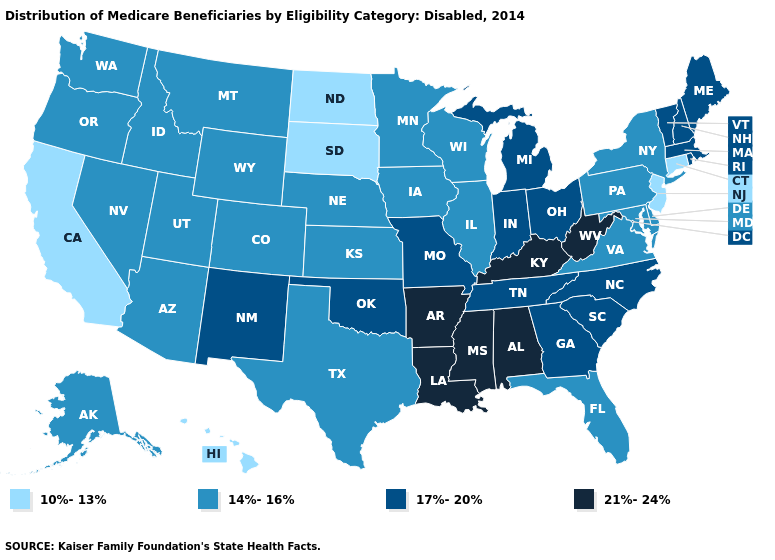What is the value of Hawaii?
Give a very brief answer. 10%-13%. What is the value of Connecticut?
Give a very brief answer. 10%-13%. What is the value of Colorado?
Write a very short answer. 14%-16%. Which states have the lowest value in the USA?
Quick response, please. California, Connecticut, Hawaii, New Jersey, North Dakota, South Dakota. Which states have the lowest value in the USA?
Keep it brief. California, Connecticut, Hawaii, New Jersey, North Dakota, South Dakota. Which states hav the highest value in the South?
Answer briefly. Alabama, Arkansas, Kentucky, Louisiana, Mississippi, West Virginia. Does Mississippi have the highest value in the USA?
Give a very brief answer. Yes. How many symbols are there in the legend?
Concise answer only. 4. Which states have the lowest value in the West?
Be succinct. California, Hawaii. Which states have the lowest value in the USA?
Answer briefly. California, Connecticut, Hawaii, New Jersey, North Dakota, South Dakota. Which states have the lowest value in the South?
Keep it brief. Delaware, Florida, Maryland, Texas, Virginia. Is the legend a continuous bar?
Keep it brief. No. What is the value of Rhode Island?
Keep it brief. 17%-20%. What is the highest value in the USA?
Answer briefly. 21%-24%. What is the value of Wisconsin?
Write a very short answer. 14%-16%. 